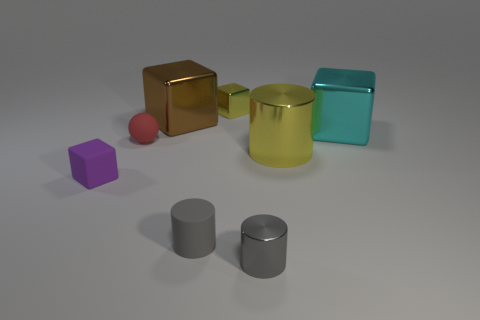Do the matte cylinder and the small metallic cylinder have the same color?
Provide a short and direct response. Yes. Is there a purple metal cube of the same size as the yellow cylinder?
Your answer should be very brief. No. What is the size of the metallic cube that is the same color as the big cylinder?
Provide a short and direct response. Small. What material is the tiny block that is on the right side of the tiny purple rubber block?
Your answer should be compact. Metal. Is the number of cyan shiny things that are behind the cyan shiny block the same as the number of purple blocks that are behind the matte ball?
Your answer should be compact. Yes. Does the shiny thing in front of the small gray matte cylinder have the same size as the yellow metallic thing that is in front of the yellow cube?
Give a very brief answer. No. What number of tiny shiny blocks are the same color as the large cylinder?
Your answer should be very brief. 1. What is the material of the object that is the same color as the small shiny cylinder?
Keep it short and to the point. Rubber. Are there more metal things on the right side of the small red ball than big metallic cubes?
Give a very brief answer. Yes. Is the shape of the purple rubber thing the same as the cyan object?
Offer a terse response. Yes. 